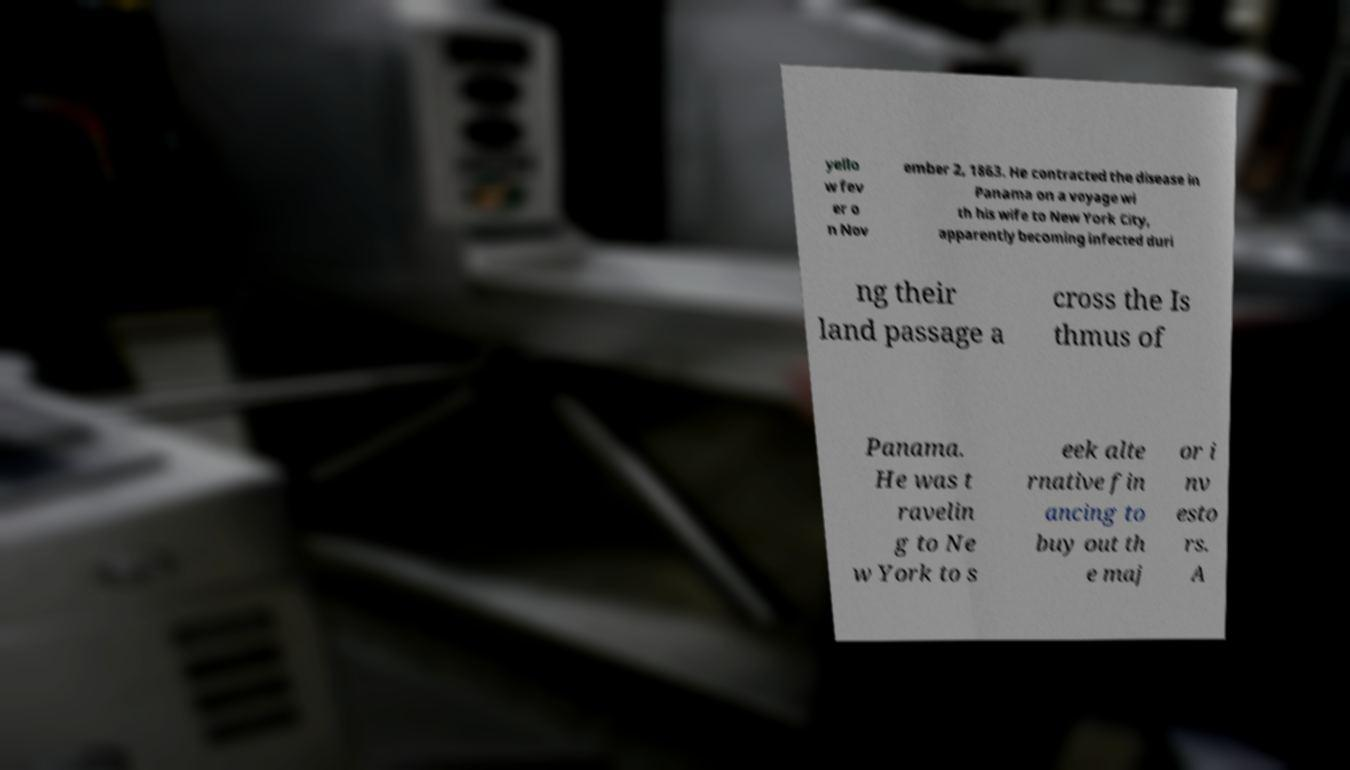I need the written content from this picture converted into text. Can you do that? yello w fev er o n Nov ember 2, 1863. He contracted the disease in Panama on a voyage wi th his wife to New York City, apparently becoming infected duri ng their land passage a cross the Is thmus of Panama. He was t ravelin g to Ne w York to s eek alte rnative fin ancing to buy out th e maj or i nv esto rs. A 